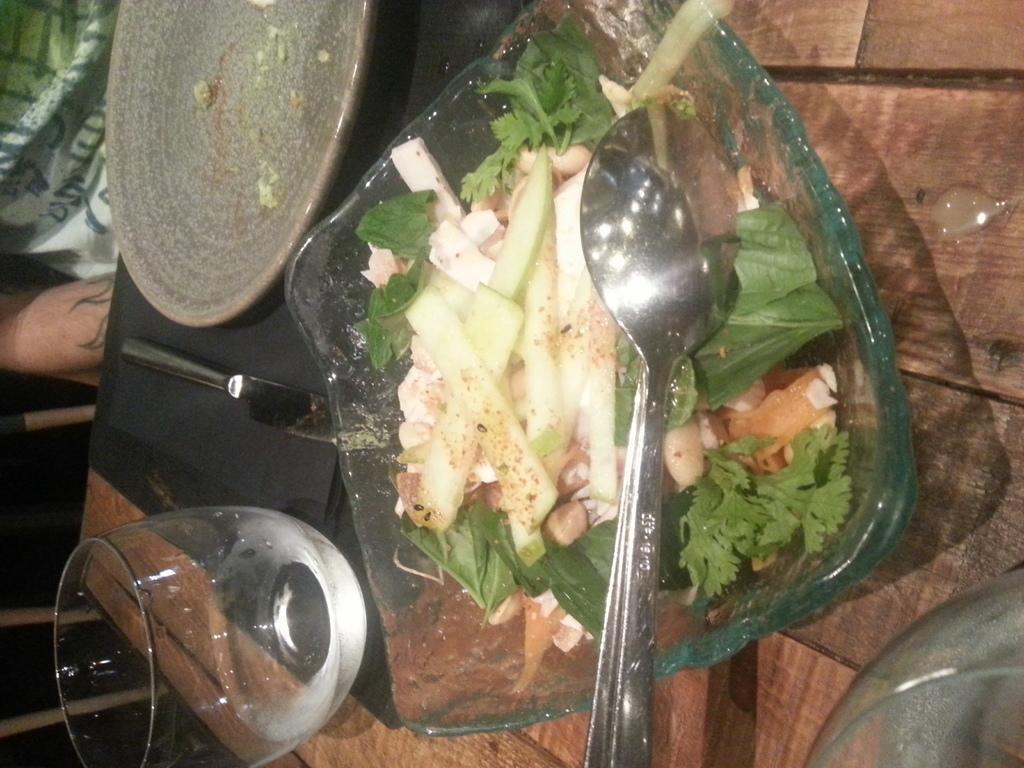Please provide a concise description of this image. This is table. On the table there is a plate, glass, spoon, bowl, and food. Here we can see a person. 